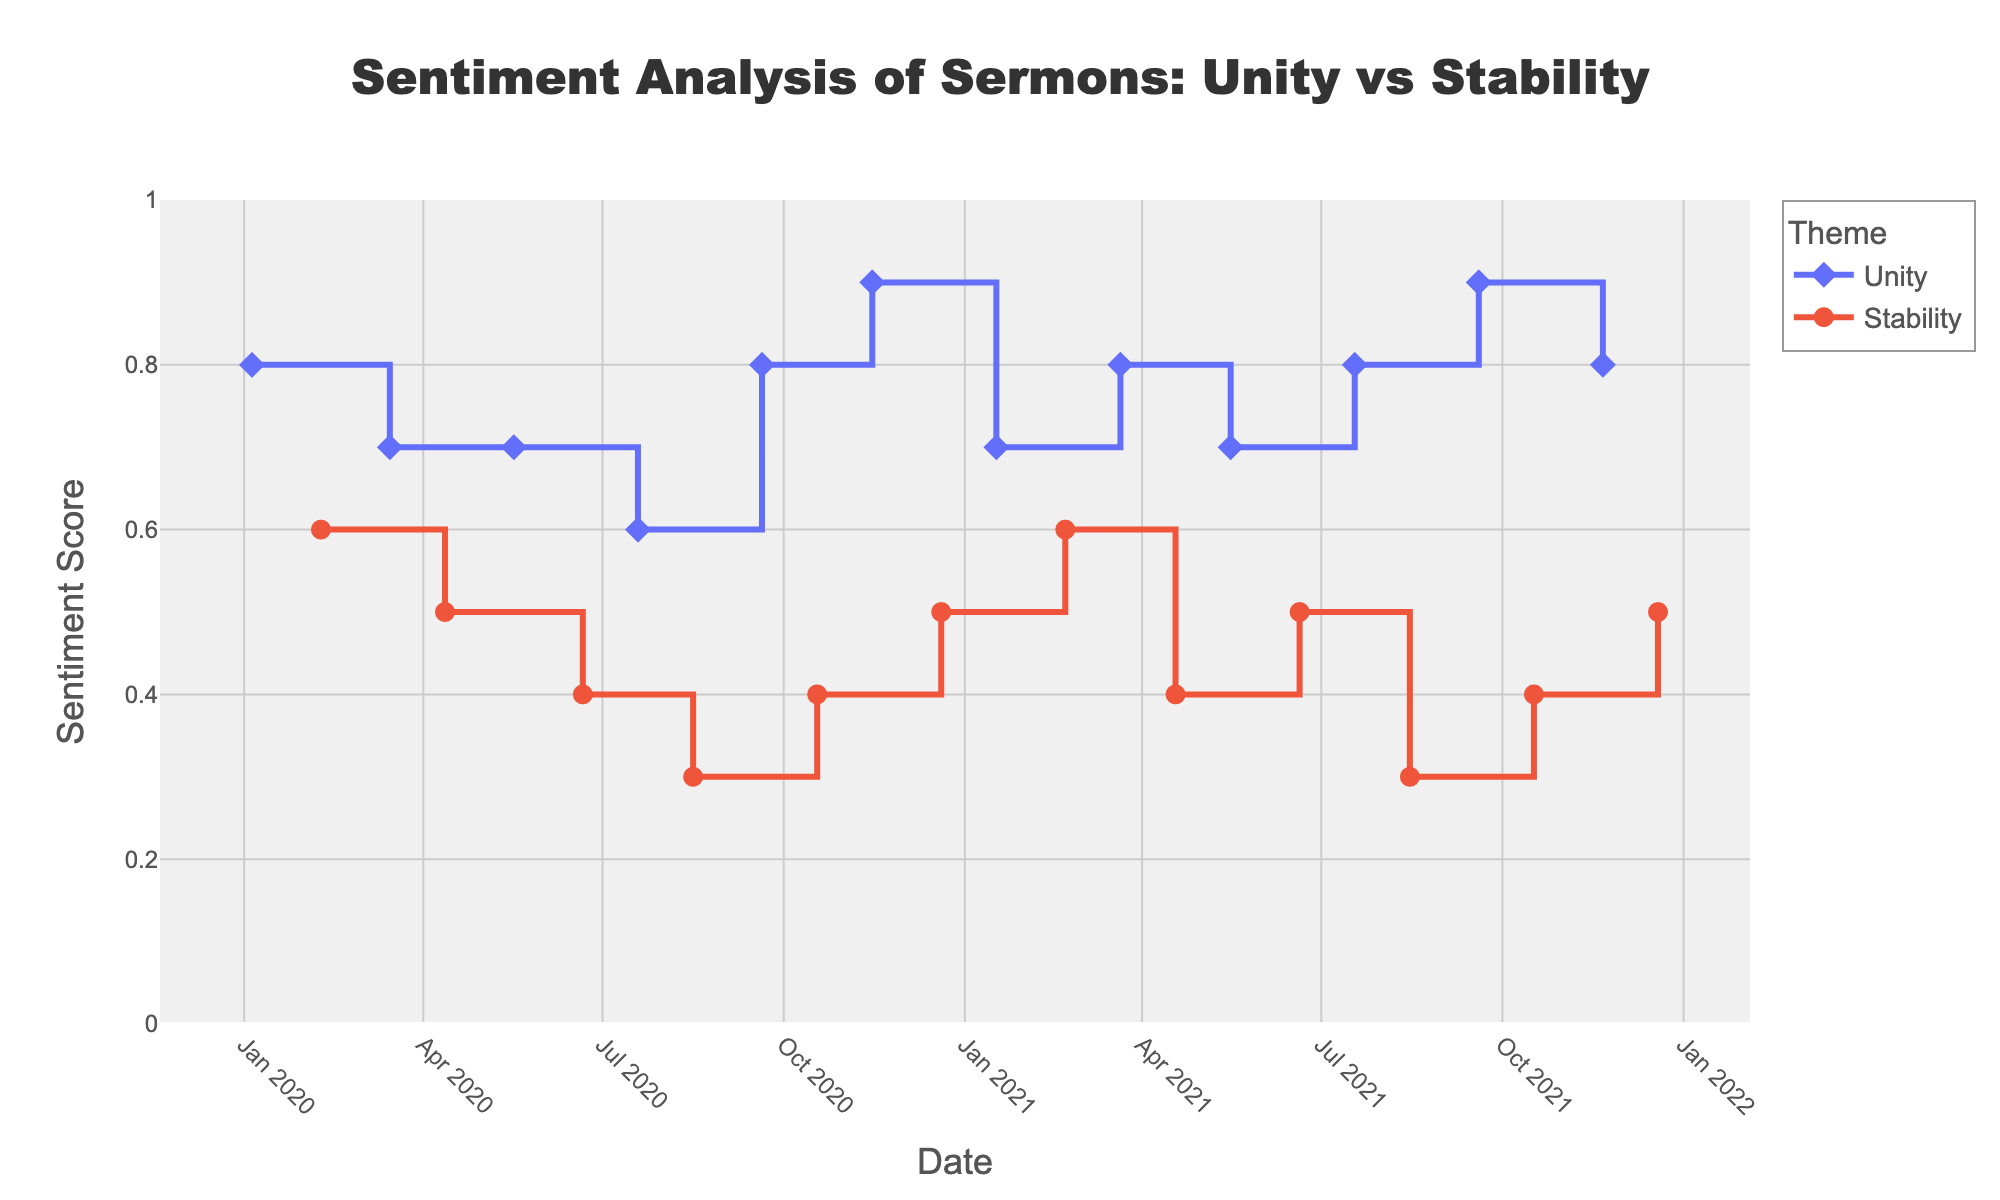How many data points are there for each theme? The plot shows lines and markers for each theme, 'Unity' and 'Stability'. By counting the number of markers (diamonds for Unity and circles for Stability), we can find that Unity has 12 data points and Stability also has 12 data points.
Answer: Unity: 12, Stability: 12 In which months did the 'Unity' theme have the highest sentiment scores? By looking at the highest points on the Unity line (diamonds), we can see that the highest sentiment scores of 0.9 occur in November 2020 and September 2021.
Answer: November 2020, September 2021 How did the sentiment score for 'Stability' in December 2020 compare with July 2021? The plot shows that the sentiment score for Stability in December 2020 is 0.5 and in July 2021 it is 0.3. Comparing these values indicates that the sentiment score decreased.
Answer: Decreased What is the average sentiment score for 'Unity' theme over the entire period? The sentiment scores for Unity are: 0.8, 0.7, 0.7, 0.6, 0.8, 0.9, 0.7, 0.8, 0.9, 0.8. Summing these gives 8.0, and there are 10 data points, so the average is 8.0/10.
Answer: 0.8 What is the overall trend of the sentiment score for 'Stability' theme from January 2020 to December 2021? By observing the line for Stability (circles), the sentiment scores generally start at 0.6, then fluctuate downward and upward but generally trend downward with lower spikes towards the end of the period, starting high and ending lower.
Answer: Downward trend Which theme had a more consistent sentiment score over the entire period? By comparing the jaggedness of the lines, Unity has less variation with most scores between 0.6 and 0.9, while Stability fluctuates more widely between 0.3 and 0.6. Hence, Unity's sentiment scores are more consistent.
Answer: Unity What is the difference in sentiment scores for 'Unity' between January 2020 and July 2021? The sentiment score for Unity in January 2020 is 0.8 and in July 2021 is 0.8. The difference is 0.8 - 0.8.
Answer: 0 Compare the highest sentiment scores for 'Unity' and 'Stability' throughout the period. The highest sentiment score for Unity is 0.9, occurring twice, and for Stability, the highest sentiment is 0.6. Comparing these shows Unity has the higher peak.
Answer: Unity Do all months show data points for both themes? By observing the points on the plot, every month between January 2020 and December 2021 has associated data points for both Unity and Stability, implying full monthly observations for both themes.
Answer: Yes 